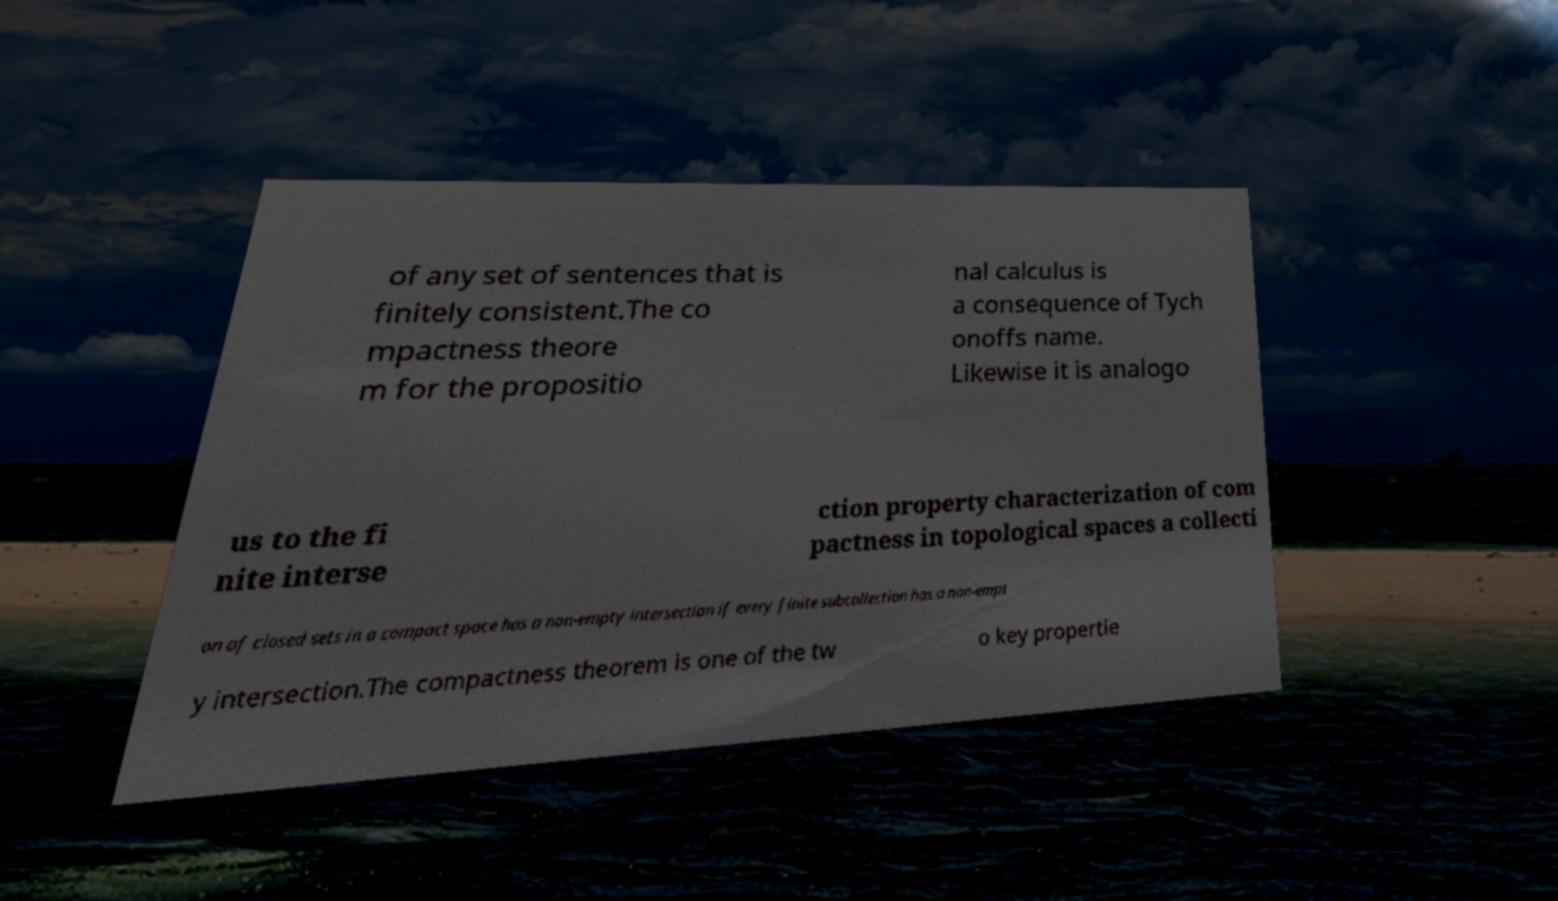Could you extract and type out the text from this image? of any set of sentences that is finitely consistent.The co mpactness theore m for the propositio nal calculus is a consequence of Tych onoffs name. Likewise it is analogo us to the fi nite interse ction property characterization of com pactness in topological spaces a collecti on of closed sets in a compact space has a non-empty intersection if every finite subcollection has a non-empt y intersection.The compactness theorem is one of the tw o key propertie 